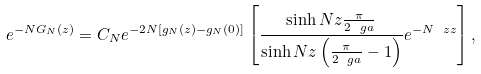Convert formula to latex. <formula><loc_0><loc_0><loc_500><loc_500>e ^ { - N G _ { N } ( z ) } = C _ { N } e ^ { - 2 N [ g _ { N } ( z ) - g _ { N } ( 0 ) ] } \left [ \frac { \sinh N z \frac { \pi } { 2 \ g a } } { \sinh N z \left ( \frac { \pi } { 2 \ g a } - 1 \right ) } e ^ { - N \ z z } \right ] ,</formula> 